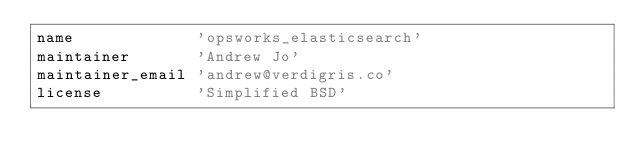<code> <loc_0><loc_0><loc_500><loc_500><_Ruby_>name             'opsworks_elasticsearch'
maintainer       'Andrew Jo'
maintainer_email 'andrew@verdigris.co'
license          'Simplified BSD'</code> 